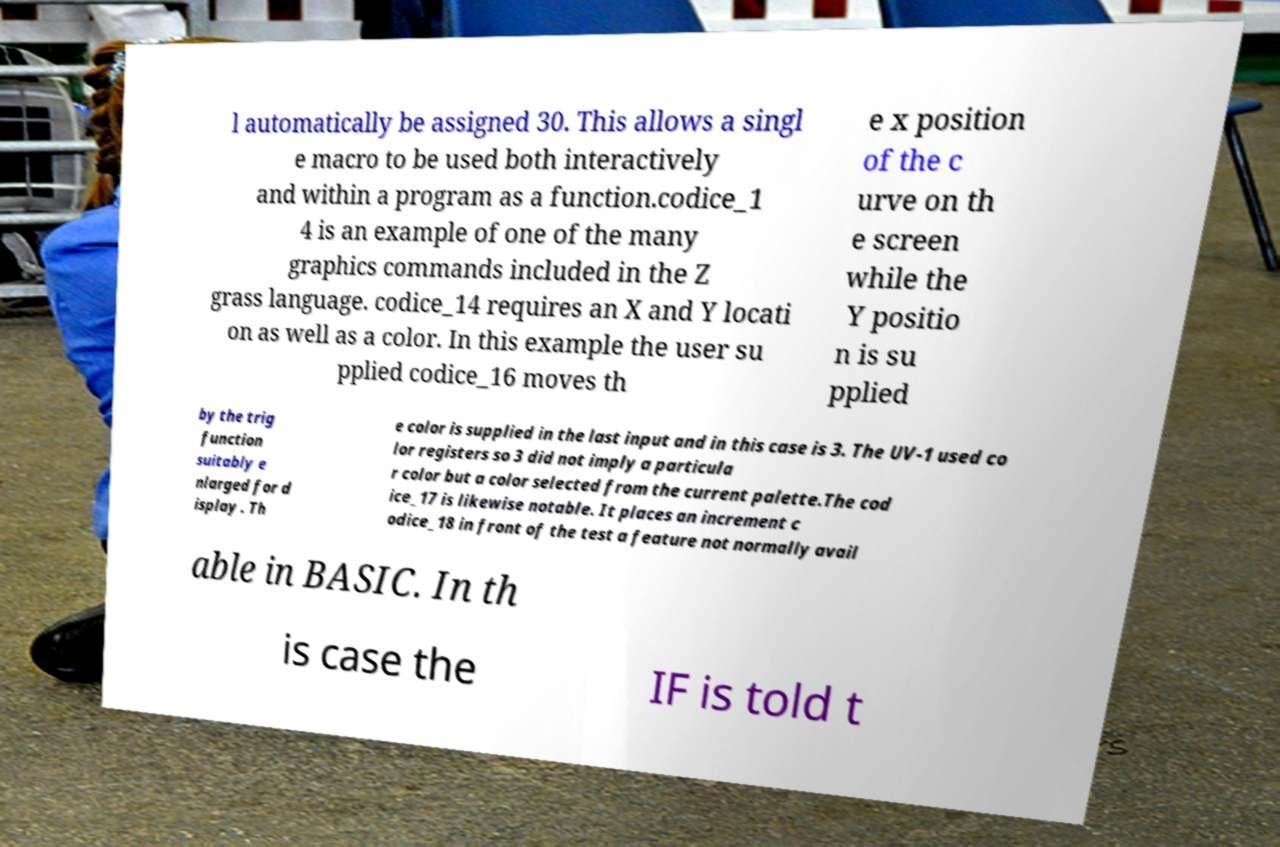Could you assist in decoding the text presented in this image and type it out clearly? l automatically be assigned 30. This allows a singl e macro to be used both interactively and within a program as a function.codice_1 4 is an example of one of the many graphics commands included in the Z grass language. codice_14 requires an X and Y locati on as well as a color. In this example the user su pplied codice_16 moves th e x position of the c urve on th e screen while the Y positio n is su pplied by the trig function suitably e nlarged for d isplay . Th e color is supplied in the last input and in this case is 3. The UV-1 used co lor registers so 3 did not imply a particula r color but a color selected from the current palette.The cod ice_17 is likewise notable. It places an increment c odice_18 in front of the test a feature not normally avail able in BASIC. In th is case the IF is told t 